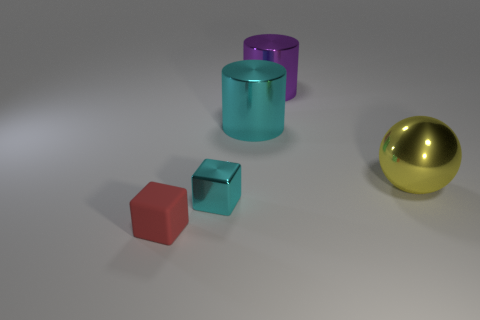Add 2 metallic balls. How many objects exist? 7 Subtract all cubes. How many objects are left? 3 Add 2 large purple cylinders. How many large purple cylinders exist? 3 Subtract 0 brown cylinders. How many objects are left? 5 Subtract all big cyan metal objects. Subtract all big purple metallic cylinders. How many objects are left? 3 Add 3 tiny cubes. How many tiny cubes are left? 5 